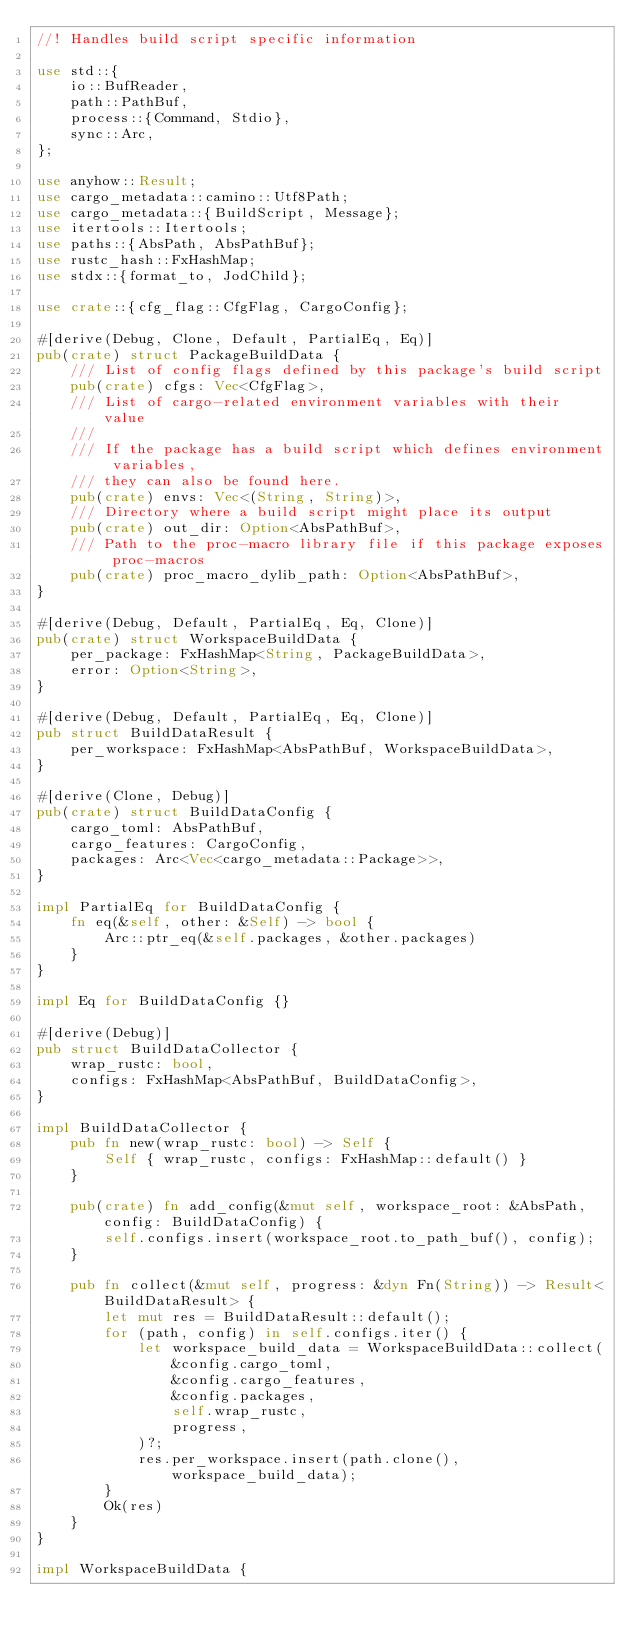Convert code to text. <code><loc_0><loc_0><loc_500><loc_500><_Rust_>//! Handles build script specific information

use std::{
    io::BufReader,
    path::PathBuf,
    process::{Command, Stdio},
    sync::Arc,
};

use anyhow::Result;
use cargo_metadata::camino::Utf8Path;
use cargo_metadata::{BuildScript, Message};
use itertools::Itertools;
use paths::{AbsPath, AbsPathBuf};
use rustc_hash::FxHashMap;
use stdx::{format_to, JodChild};

use crate::{cfg_flag::CfgFlag, CargoConfig};

#[derive(Debug, Clone, Default, PartialEq, Eq)]
pub(crate) struct PackageBuildData {
    /// List of config flags defined by this package's build script
    pub(crate) cfgs: Vec<CfgFlag>,
    /// List of cargo-related environment variables with their value
    ///
    /// If the package has a build script which defines environment variables,
    /// they can also be found here.
    pub(crate) envs: Vec<(String, String)>,
    /// Directory where a build script might place its output
    pub(crate) out_dir: Option<AbsPathBuf>,
    /// Path to the proc-macro library file if this package exposes proc-macros
    pub(crate) proc_macro_dylib_path: Option<AbsPathBuf>,
}

#[derive(Debug, Default, PartialEq, Eq, Clone)]
pub(crate) struct WorkspaceBuildData {
    per_package: FxHashMap<String, PackageBuildData>,
    error: Option<String>,
}

#[derive(Debug, Default, PartialEq, Eq, Clone)]
pub struct BuildDataResult {
    per_workspace: FxHashMap<AbsPathBuf, WorkspaceBuildData>,
}

#[derive(Clone, Debug)]
pub(crate) struct BuildDataConfig {
    cargo_toml: AbsPathBuf,
    cargo_features: CargoConfig,
    packages: Arc<Vec<cargo_metadata::Package>>,
}

impl PartialEq for BuildDataConfig {
    fn eq(&self, other: &Self) -> bool {
        Arc::ptr_eq(&self.packages, &other.packages)
    }
}

impl Eq for BuildDataConfig {}

#[derive(Debug)]
pub struct BuildDataCollector {
    wrap_rustc: bool,
    configs: FxHashMap<AbsPathBuf, BuildDataConfig>,
}

impl BuildDataCollector {
    pub fn new(wrap_rustc: bool) -> Self {
        Self { wrap_rustc, configs: FxHashMap::default() }
    }

    pub(crate) fn add_config(&mut self, workspace_root: &AbsPath, config: BuildDataConfig) {
        self.configs.insert(workspace_root.to_path_buf(), config);
    }

    pub fn collect(&mut self, progress: &dyn Fn(String)) -> Result<BuildDataResult> {
        let mut res = BuildDataResult::default();
        for (path, config) in self.configs.iter() {
            let workspace_build_data = WorkspaceBuildData::collect(
                &config.cargo_toml,
                &config.cargo_features,
                &config.packages,
                self.wrap_rustc,
                progress,
            )?;
            res.per_workspace.insert(path.clone(), workspace_build_data);
        }
        Ok(res)
    }
}

impl WorkspaceBuildData {</code> 